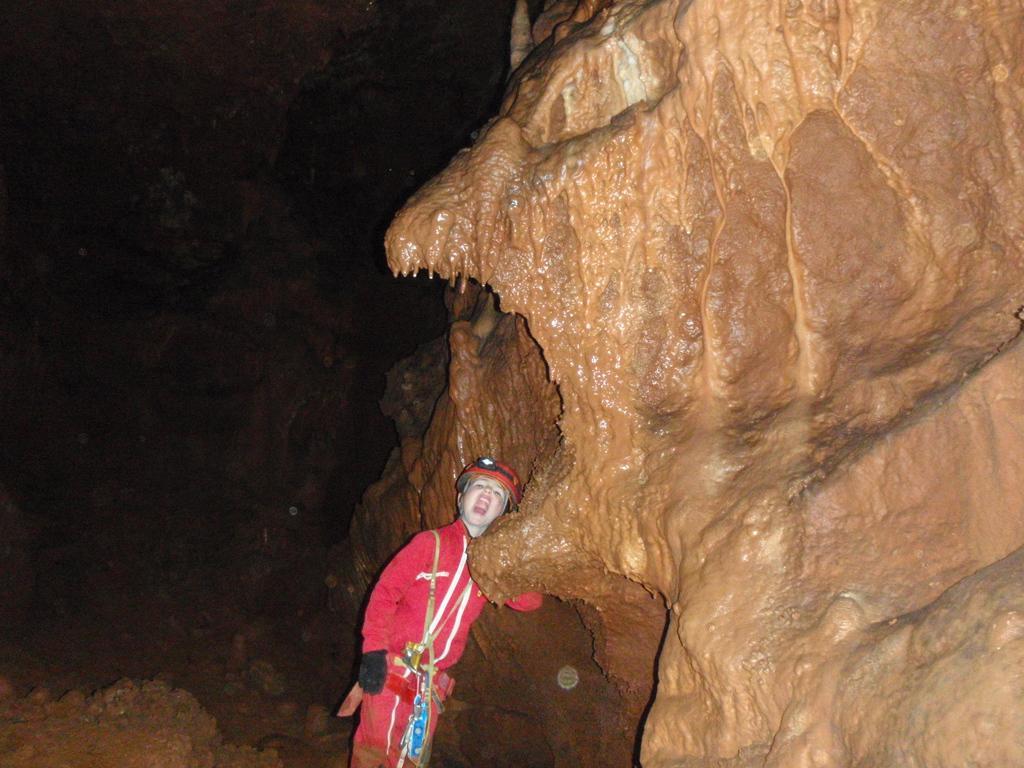Please provide a concise description of this image. In this image, we can see sculpture carved on rocks. We can also see a boy wearing red color clothes and standing. 